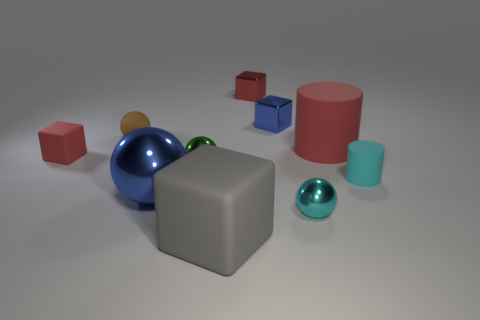What is the size of the blue object that is the same shape as the small brown thing?
Keep it short and to the point. Large. There is a small metallic ball right of the blue metallic thing that is behind the small thing right of the red rubber cylinder; what is its color?
Offer a terse response. Cyan. Does the big block have the same material as the big sphere?
Offer a very short reply. No. Are there any tiny shiny objects in front of the large matte object that is on the right side of the metal thing that is in front of the large blue thing?
Your answer should be compact. Yes. Is the color of the large cylinder the same as the tiny rubber cube?
Your answer should be compact. Yes. Are there fewer gray things than yellow spheres?
Offer a very short reply. No. Are the large thing in front of the cyan metal thing and the red object that is on the left side of the blue metal ball made of the same material?
Make the answer very short. Yes. Are there fewer big gray blocks behind the tiny brown rubber thing than tiny metal things?
Ensure brevity in your answer.  Yes. How many blue shiny objects are on the right side of the small red object in front of the blue metal cube?
Provide a short and direct response. 2. What size is the sphere that is in front of the big red cylinder and left of the tiny green shiny thing?
Ensure brevity in your answer.  Large. 